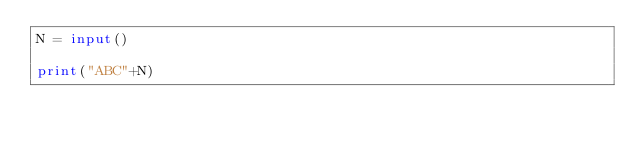Convert code to text. <code><loc_0><loc_0><loc_500><loc_500><_Python_>N = input()

print("ABC"+N)
</code> 